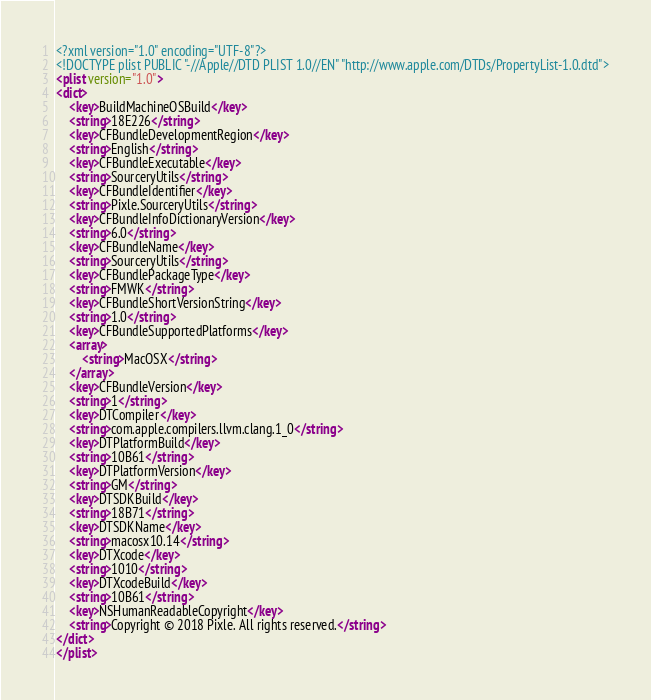Convert code to text. <code><loc_0><loc_0><loc_500><loc_500><_XML_><?xml version="1.0" encoding="UTF-8"?>
<!DOCTYPE plist PUBLIC "-//Apple//DTD PLIST 1.0//EN" "http://www.apple.com/DTDs/PropertyList-1.0.dtd">
<plist version="1.0">
<dict>
	<key>BuildMachineOSBuild</key>
	<string>18E226</string>
	<key>CFBundleDevelopmentRegion</key>
	<string>English</string>
	<key>CFBundleExecutable</key>
	<string>SourceryUtils</string>
	<key>CFBundleIdentifier</key>
	<string>Pixle.SourceryUtils</string>
	<key>CFBundleInfoDictionaryVersion</key>
	<string>6.0</string>
	<key>CFBundleName</key>
	<string>SourceryUtils</string>
	<key>CFBundlePackageType</key>
	<string>FMWK</string>
	<key>CFBundleShortVersionString</key>
	<string>1.0</string>
	<key>CFBundleSupportedPlatforms</key>
	<array>
		<string>MacOSX</string>
	</array>
	<key>CFBundleVersion</key>
	<string>1</string>
	<key>DTCompiler</key>
	<string>com.apple.compilers.llvm.clang.1_0</string>
	<key>DTPlatformBuild</key>
	<string>10B61</string>
	<key>DTPlatformVersion</key>
	<string>GM</string>
	<key>DTSDKBuild</key>
	<string>18B71</string>
	<key>DTSDKName</key>
	<string>macosx10.14</string>
	<key>DTXcode</key>
	<string>1010</string>
	<key>DTXcodeBuild</key>
	<string>10B61</string>
	<key>NSHumanReadableCopyright</key>
	<string>Copyright © 2018 Pixle. All rights reserved.</string>
</dict>
</plist>
</code> 